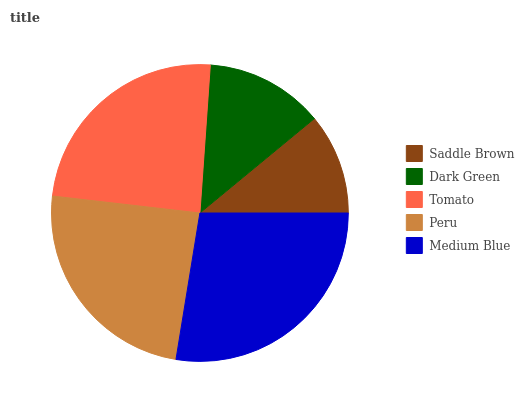Is Saddle Brown the minimum?
Answer yes or no. Yes. Is Medium Blue the maximum?
Answer yes or no. Yes. Is Dark Green the minimum?
Answer yes or no. No. Is Dark Green the maximum?
Answer yes or no. No. Is Dark Green greater than Saddle Brown?
Answer yes or no. Yes. Is Saddle Brown less than Dark Green?
Answer yes or no. Yes. Is Saddle Brown greater than Dark Green?
Answer yes or no. No. Is Dark Green less than Saddle Brown?
Answer yes or no. No. Is Peru the high median?
Answer yes or no. Yes. Is Peru the low median?
Answer yes or no. Yes. Is Medium Blue the high median?
Answer yes or no. No. Is Tomato the low median?
Answer yes or no. No. 